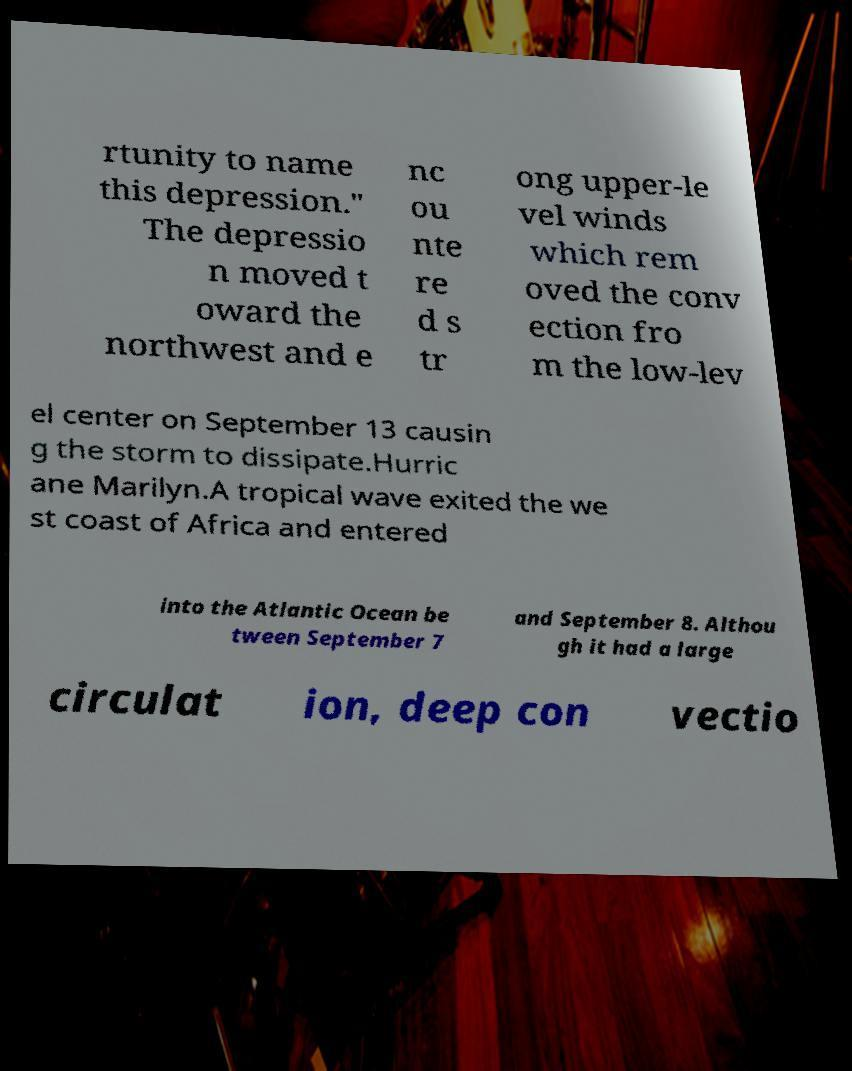Can you accurately transcribe the text from the provided image for me? rtunity to name this depression." The depressio n moved t oward the northwest and e nc ou nte re d s tr ong upper-le vel winds which rem oved the conv ection fro m the low-lev el center on September 13 causin g the storm to dissipate.Hurric ane Marilyn.A tropical wave exited the we st coast of Africa and entered into the Atlantic Ocean be tween September 7 and September 8. Althou gh it had a large circulat ion, deep con vectio 